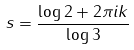<formula> <loc_0><loc_0><loc_500><loc_500>s = \frac { \log 2 + 2 \pi i k } { \log 3 }</formula> 